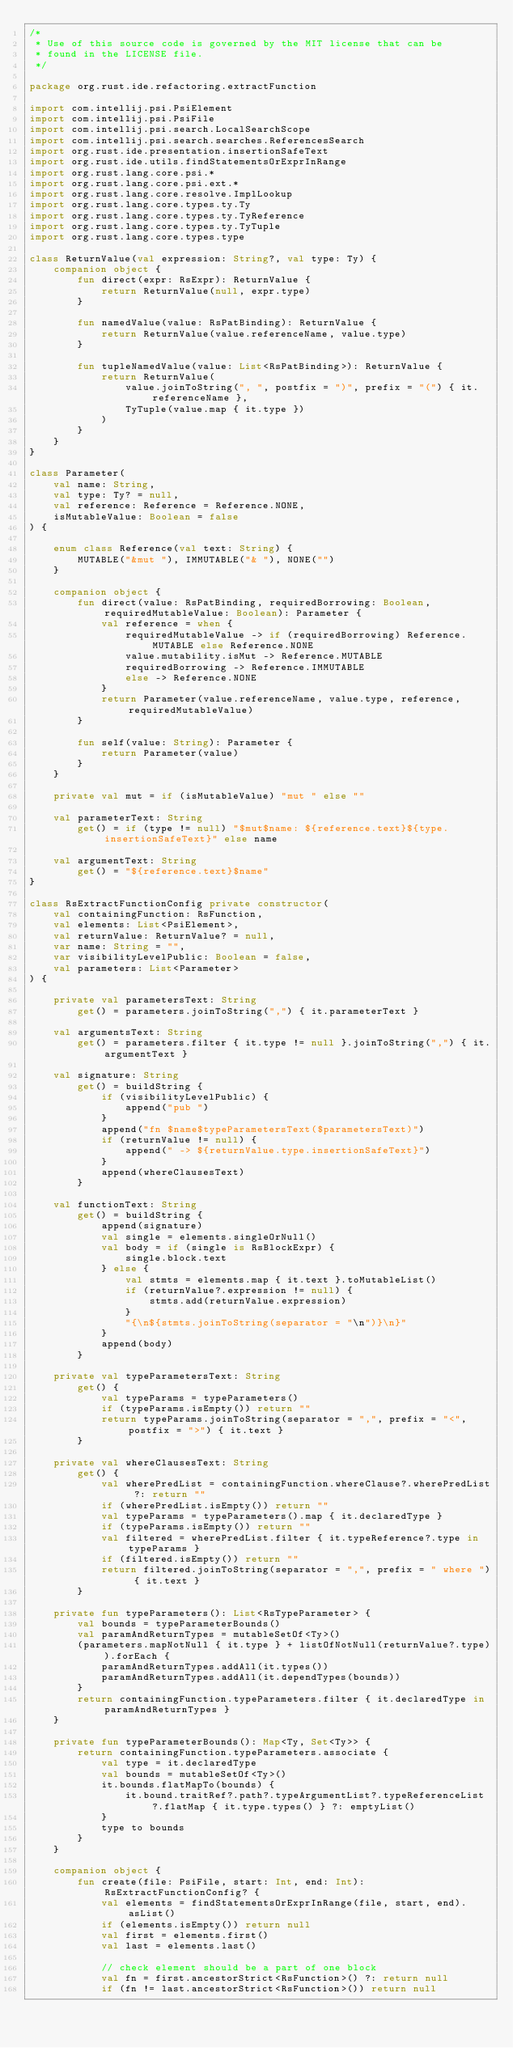Convert code to text. <code><loc_0><loc_0><loc_500><loc_500><_Kotlin_>/*
 * Use of this source code is governed by the MIT license that can be
 * found in the LICENSE file.
 */

package org.rust.ide.refactoring.extractFunction

import com.intellij.psi.PsiElement
import com.intellij.psi.PsiFile
import com.intellij.psi.search.LocalSearchScope
import com.intellij.psi.search.searches.ReferencesSearch
import org.rust.ide.presentation.insertionSafeText
import org.rust.ide.utils.findStatementsOrExprInRange
import org.rust.lang.core.psi.*
import org.rust.lang.core.psi.ext.*
import org.rust.lang.core.resolve.ImplLookup
import org.rust.lang.core.types.ty.Ty
import org.rust.lang.core.types.ty.TyReference
import org.rust.lang.core.types.ty.TyTuple
import org.rust.lang.core.types.type

class ReturnValue(val expression: String?, val type: Ty) {
    companion object {
        fun direct(expr: RsExpr): ReturnValue {
            return ReturnValue(null, expr.type)
        }

        fun namedValue(value: RsPatBinding): ReturnValue {
            return ReturnValue(value.referenceName, value.type)
        }

        fun tupleNamedValue(value: List<RsPatBinding>): ReturnValue {
            return ReturnValue(
                value.joinToString(", ", postfix = ")", prefix = "(") { it.referenceName },
                TyTuple(value.map { it.type })
            )
        }
    }
}

class Parameter(
    val name: String,
    val type: Ty? = null,
    val reference: Reference = Reference.NONE,
    isMutableValue: Boolean = false
) {

    enum class Reference(val text: String) {
        MUTABLE("&mut "), IMMUTABLE("& "), NONE("")
    }

    companion object {
        fun direct(value: RsPatBinding, requiredBorrowing: Boolean, requiredMutableValue: Boolean): Parameter {
            val reference = when {
                requiredMutableValue -> if (requiredBorrowing) Reference.MUTABLE else Reference.NONE
                value.mutability.isMut -> Reference.MUTABLE
                requiredBorrowing -> Reference.IMMUTABLE
                else -> Reference.NONE
            }
            return Parameter(value.referenceName, value.type, reference, requiredMutableValue)
        }

        fun self(value: String): Parameter {
            return Parameter(value)
        }
    }

    private val mut = if (isMutableValue) "mut " else ""

    val parameterText: String
        get() = if (type != null) "$mut$name: ${reference.text}${type.insertionSafeText}" else name

    val argumentText: String
        get() = "${reference.text}$name"
}

class RsExtractFunctionConfig private constructor(
    val containingFunction: RsFunction,
    val elements: List<PsiElement>,
    val returnValue: ReturnValue? = null,
    var name: String = "",
    var visibilityLevelPublic: Boolean = false,
    val parameters: List<Parameter>
) {

    private val parametersText: String
        get() = parameters.joinToString(",") { it.parameterText }

    val argumentsText: String
        get() = parameters.filter { it.type != null }.joinToString(",") { it.argumentText }

    val signature: String
        get() = buildString {
            if (visibilityLevelPublic) {
                append("pub ")
            }
            append("fn $name$typeParametersText($parametersText)")
            if (returnValue != null) {
                append(" -> ${returnValue.type.insertionSafeText}")
            }
            append(whereClausesText)
        }

    val functionText: String
        get() = buildString {
            append(signature)
            val single = elements.singleOrNull()
            val body = if (single is RsBlockExpr) {
                single.block.text
            } else {
                val stmts = elements.map { it.text }.toMutableList()
                if (returnValue?.expression != null) {
                    stmts.add(returnValue.expression)
                }
                "{\n${stmts.joinToString(separator = "\n")}\n}"
            }
            append(body)
        }

    private val typeParametersText: String
        get() {
            val typeParams = typeParameters()
            if (typeParams.isEmpty()) return ""
            return typeParams.joinToString(separator = ",", prefix = "<", postfix = ">") { it.text }
        }

    private val whereClausesText: String
        get() {
            val wherePredList = containingFunction.whereClause?.wherePredList ?: return ""
            if (wherePredList.isEmpty()) return ""
            val typeParams = typeParameters().map { it.declaredType }
            if (typeParams.isEmpty()) return ""
            val filtered = wherePredList.filter { it.typeReference?.type in typeParams }
            if (filtered.isEmpty()) return ""
            return filtered.joinToString(separator = ",", prefix = " where ") { it.text }
        }

    private fun typeParameters(): List<RsTypeParameter> {
        val bounds = typeParameterBounds()
        val paramAndReturnTypes = mutableSetOf<Ty>()
        (parameters.mapNotNull { it.type } + listOfNotNull(returnValue?.type)).forEach {
            paramAndReturnTypes.addAll(it.types())
            paramAndReturnTypes.addAll(it.dependTypes(bounds))
        }
        return containingFunction.typeParameters.filter { it.declaredType in paramAndReturnTypes }
    }

    private fun typeParameterBounds(): Map<Ty, Set<Ty>> {
        return containingFunction.typeParameters.associate {
            val type = it.declaredType
            val bounds = mutableSetOf<Ty>()
            it.bounds.flatMapTo(bounds) {
                it.bound.traitRef?.path?.typeArgumentList?.typeReferenceList?.flatMap { it.type.types() } ?: emptyList()
            }
            type to bounds
        }
    }

    companion object {
        fun create(file: PsiFile, start: Int, end: Int): RsExtractFunctionConfig? {
            val elements = findStatementsOrExprInRange(file, start, end).asList()
            if (elements.isEmpty()) return null
            val first = elements.first()
            val last = elements.last()

            // check element should be a part of one block
            val fn = first.ancestorStrict<RsFunction>() ?: return null
            if (fn != last.ancestorStrict<RsFunction>()) return null
</code> 